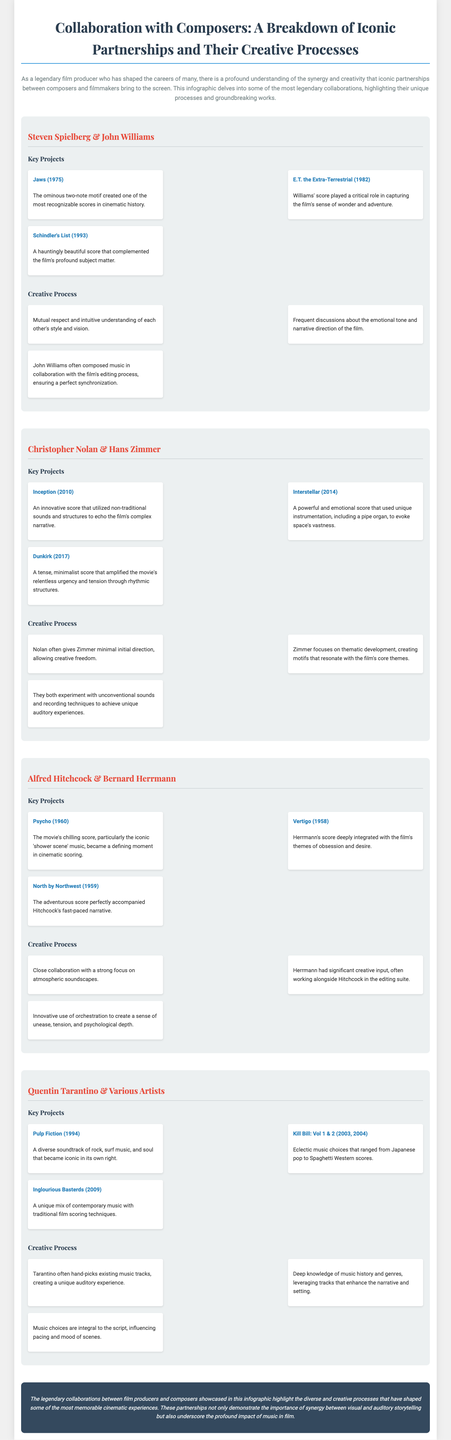What are the three key projects of Steven Spielberg & John Williams? The key projects are listed as Jaws, E.T. the Extra-Terrestrial, and Schindler's List.
Answer: Jaws, E.T. the Extra-Terrestrial, Schindler's List What unique instrument did Hans Zimmer use in Interstellar? The document mentions unique instrumentation, including a pipe organ, in the score for Interstellar.
Answer: Pipe organ Which collaboration is known for the chilling score in Psycho? The collaboration between Alfred Hitchcock and Bernard Herrmann is noted for the chilling score in Psycho.
Answer: Alfred Hitchcock & Bernard Herrmann What is the common theme observed in Quentin Tarantino’s projects? The document notes Tarantino's deep knowledge of music history and genres to enhance narratives, reflecting his unique auditory experience.
Answer: Unique auditory experience What color is the text for collaboration headings? The text for collaboration headings is colored with a specific shade mentioned in the style section of the document.
Answer: #e74c3c How does Hans Zimmer typically receive direction from Christopher Nolan? The document states that Nolan often gives Zimmer minimal initial direction, allowing creative freedom.
Answer: Minimal initial direction How many key projects are listed for Christopher Nolan & Hans Zimmer? The document lists three key projects for this collaboration.
Answer: Three What emotion did John Williams' score aim to capture in E.T. the Extra-Terrestrial? The document specifically mentions that the score aimed to capture a sense of wonder and adventure.
Answer: Wonder and adventure 